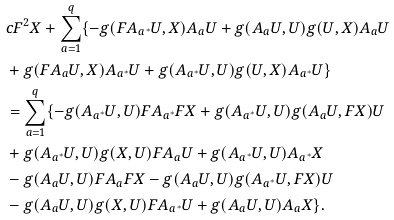Convert formula to latex. <formula><loc_0><loc_0><loc_500><loc_500>& c F ^ { 2 } X + \sum _ { a = 1 } ^ { q } \{ - g ( F A _ { a ^ { * } } U , X ) A _ { a } U + g ( A _ { a } U , U ) g ( U , X ) A _ { a } U \\ & + g ( F A _ { a } U , X ) A _ { a ^ { * } } U + g ( A _ { a ^ { * } } U , U ) g ( U , X ) A _ { a ^ { * } } U \} \\ & = \sum _ { a = 1 } ^ { q } \{ - g ( A _ { a ^ { * } } U , U ) F A _ { a ^ { * } } F X + g ( A _ { a ^ { * } } U , U ) g ( A _ { a } U , F X ) U \\ & + g ( A _ { a ^ { * } } U , U ) g ( X , U ) F A _ { a } U + g ( A _ { a ^ { * } } U , U ) A _ { a ^ { * } } X \\ & - g ( A _ { a } U , U ) F A _ { a } F X - g ( A _ { a } U , U ) g ( A _ { a ^ { * } } U , F X ) U \\ & - g ( A _ { a } U , U ) g ( X , U ) F A _ { a ^ { * } } U + g ( A _ { a } U , U ) A _ { a } X \} .</formula> 